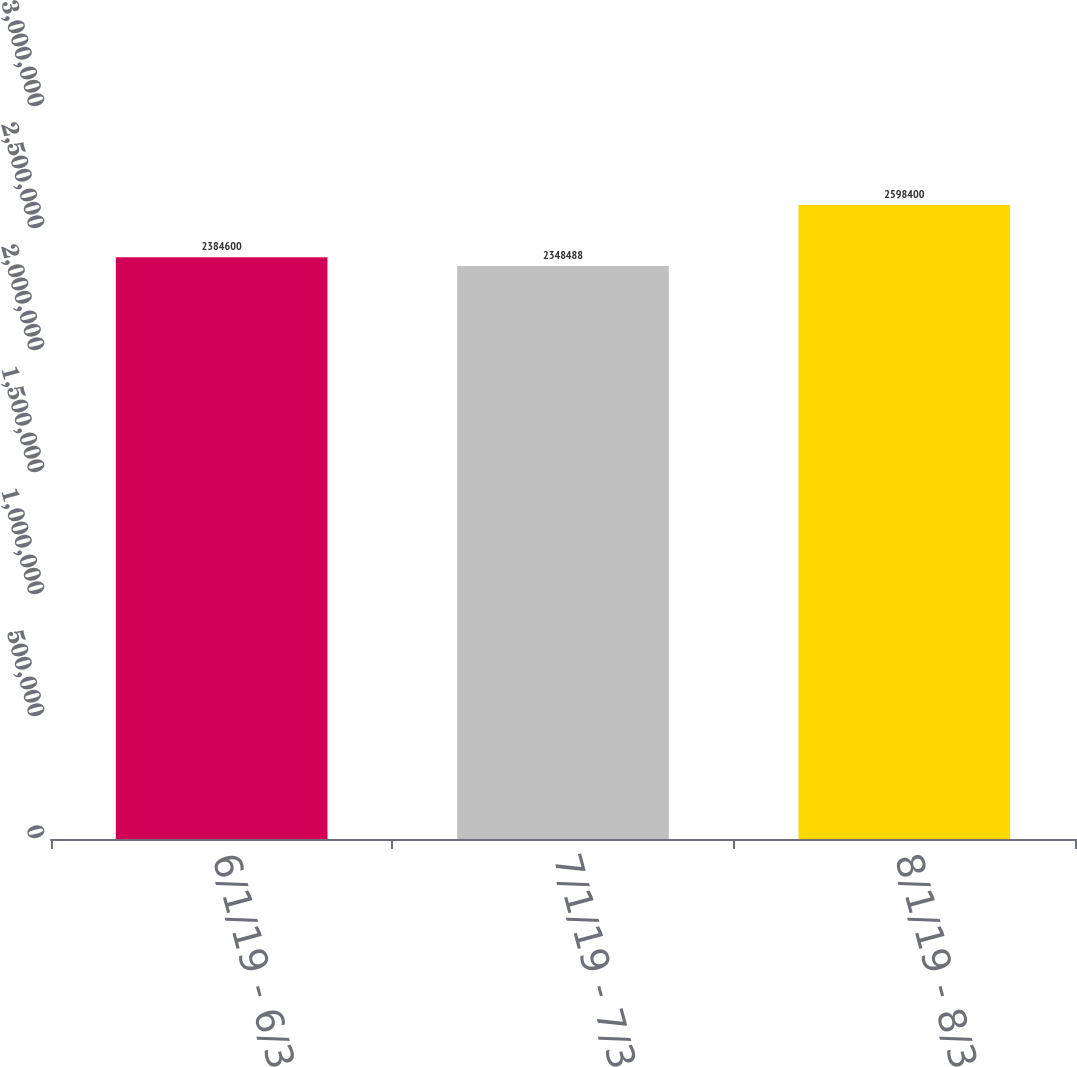Convert chart. <chart><loc_0><loc_0><loc_500><loc_500><bar_chart><fcel>6/1/19 - 6/30/19<fcel>7/1/19 - 7/31/19<fcel>8/1/19 - 8/31/19<nl><fcel>2.3846e+06<fcel>2.34849e+06<fcel>2.5984e+06<nl></chart> 